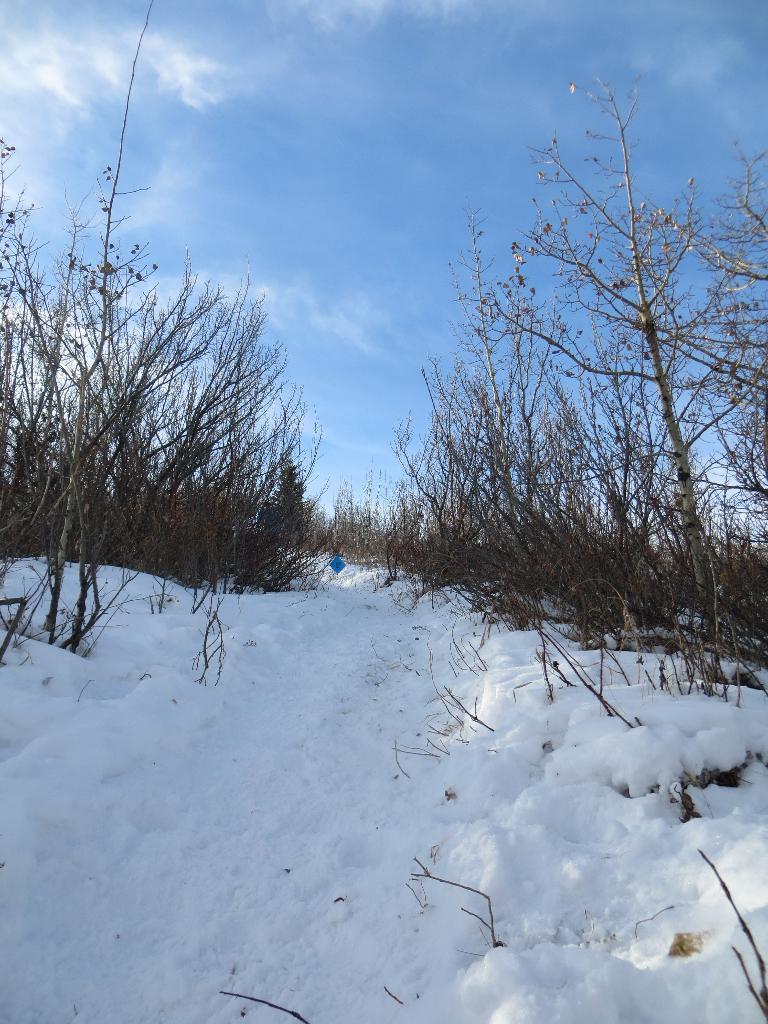Can you describe this image briefly? At the bottom of the image on the ground there is snow. And also there are plants without leaves. In the background there is sky. 